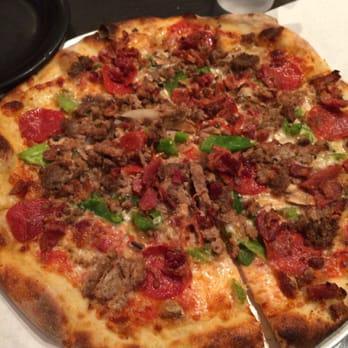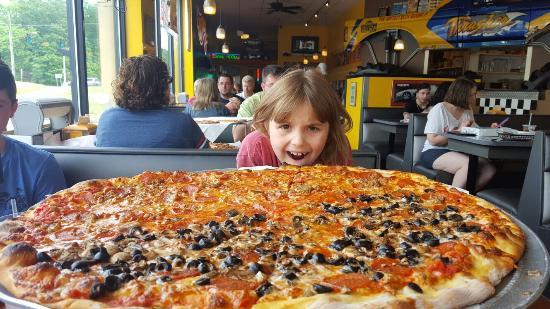The first image is the image on the left, the second image is the image on the right. For the images shown, is this caption "The left image shows a tool with a handle and a flat metal part being applied to a round pizza." true? Answer yes or no. No. The first image is the image on the left, the second image is the image on the right. Considering the images on both sides, is "The left and right image contains the same number of pizzas with at least on sitting on paper." valid? Answer yes or no. No. 